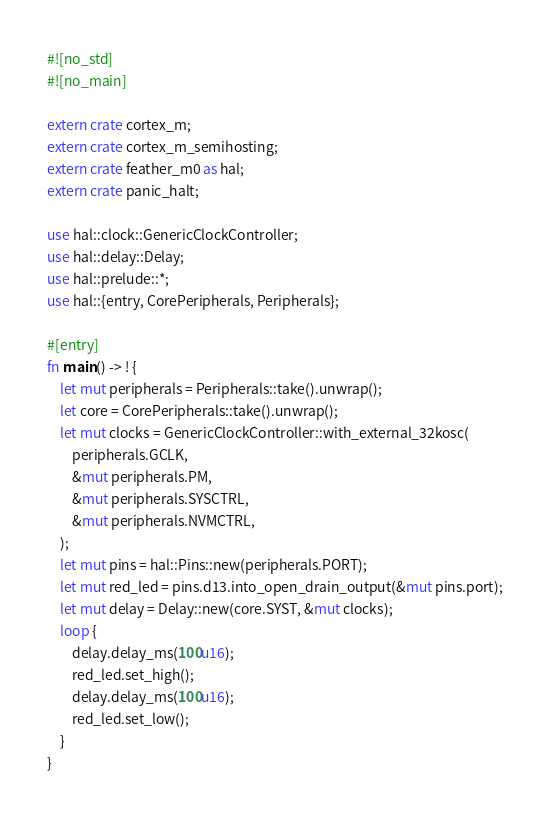<code> <loc_0><loc_0><loc_500><loc_500><_Rust_>#![no_std]
#![no_main]

extern crate cortex_m;
extern crate cortex_m_semihosting;
extern crate feather_m0 as hal;
extern crate panic_halt;

use hal::clock::GenericClockController;
use hal::delay::Delay;
use hal::prelude::*;
use hal::{entry, CorePeripherals, Peripherals};

#[entry]
fn main() -> ! {
    let mut peripherals = Peripherals::take().unwrap();
    let core = CorePeripherals::take().unwrap();
    let mut clocks = GenericClockController::with_external_32kosc(
        peripherals.GCLK,
        &mut peripherals.PM,
        &mut peripherals.SYSCTRL,
        &mut peripherals.NVMCTRL,
    );
    let mut pins = hal::Pins::new(peripherals.PORT);
    let mut red_led = pins.d13.into_open_drain_output(&mut pins.port);
    let mut delay = Delay::new(core.SYST, &mut clocks);
    loop {
        delay.delay_ms(100u16);
        red_led.set_high();
        delay.delay_ms(100u16);
        red_led.set_low();
    }
}
</code> 